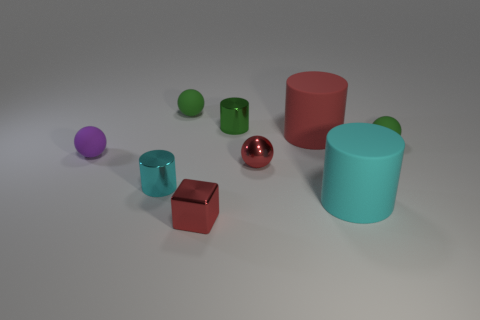Is there a big matte object that has the same shape as the cyan metal object?
Your response must be concise. Yes. There is a tiny shiny thing that is the same color as the small cube; what is its shape?
Make the answer very short. Sphere. Are there any small cylinders to the right of the green ball to the right of the small red object in front of the big cyan cylinder?
Keep it short and to the point. No. There is a cyan matte thing that is the same size as the red rubber cylinder; what shape is it?
Ensure brevity in your answer.  Cylinder. There is another large object that is the same shape as the big red object; what is its color?
Keep it short and to the point. Cyan. What number of things are big rubber cylinders or cyan rubber cylinders?
Give a very brief answer. 2. There is a cyan object right of the tiny cyan cylinder; is it the same shape as the red thing behind the small shiny sphere?
Offer a terse response. Yes. There is a tiny object that is in front of the large cyan cylinder; what shape is it?
Keep it short and to the point. Cube. Are there the same number of tiny cyan metal cylinders that are behind the large cyan cylinder and red blocks left of the green shiny cylinder?
Provide a succinct answer. Yes. How many objects are either tiny red spheres or green matte balls left of the shiny block?
Offer a terse response. 2. 